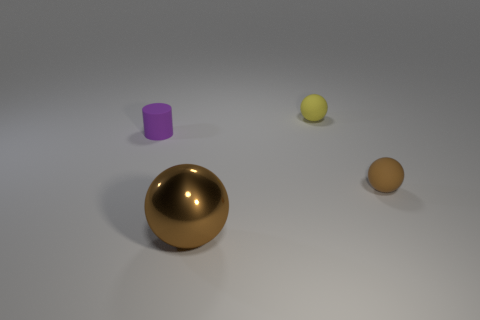Add 4 green rubber blocks. How many objects exist? 8 Subtract all cylinders. How many objects are left? 3 Subtract all tiny things. Subtract all large blue metallic things. How many objects are left? 1 Add 3 brown shiny objects. How many brown shiny objects are left? 4 Add 3 small cylinders. How many small cylinders exist? 4 Subtract 0 blue blocks. How many objects are left? 4 